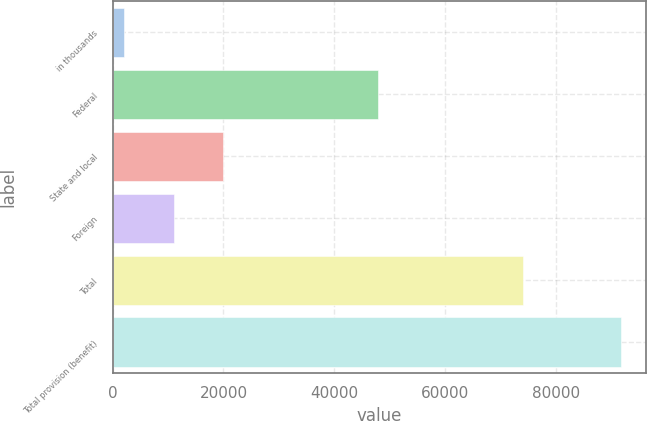<chart> <loc_0><loc_0><loc_500><loc_500><bar_chart><fcel>in thousands<fcel>Federal<fcel>State and local<fcel>Foreign<fcel>Total<fcel>Total provision (benefit)<nl><fcel>2014<fcel>47882<fcel>19949.6<fcel>10981.8<fcel>74039<fcel>91692<nl></chart> 